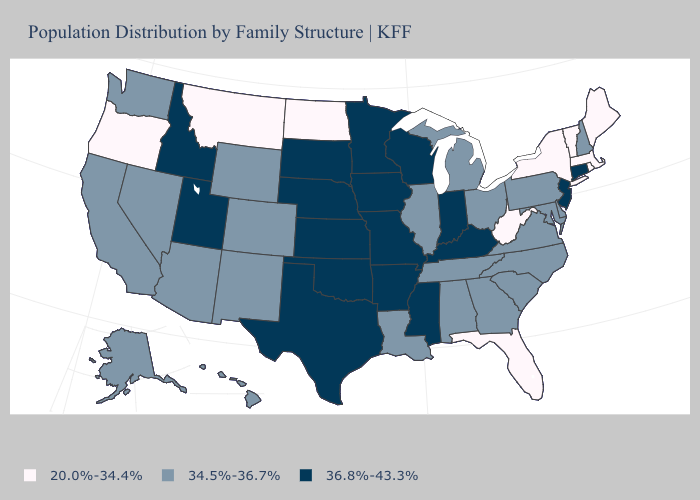Does Montana have a higher value than Georgia?
Keep it brief. No. Name the states that have a value in the range 36.8%-43.3%?
Give a very brief answer. Arkansas, Connecticut, Idaho, Indiana, Iowa, Kansas, Kentucky, Minnesota, Mississippi, Missouri, Nebraska, New Jersey, Oklahoma, South Dakota, Texas, Utah, Wisconsin. Which states have the lowest value in the South?
Keep it brief. Florida, West Virginia. What is the highest value in the USA?
Short answer required. 36.8%-43.3%. How many symbols are there in the legend?
Answer briefly. 3. What is the value of Iowa?
Write a very short answer. 36.8%-43.3%. Among the states that border Tennessee , which have the highest value?
Quick response, please. Arkansas, Kentucky, Mississippi, Missouri. What is the lowest value in the West?
Short answer required. 20.0%-34.4%. Name the states that have a value in the range 20.0%-34.4%?
Give a very brief answer. Florida, Maine, Massachusetts, Montana, New York, North Dakota, Oregon, Rhode Island, Vermont, West Virginia. Name the states that have a value in the range 34.5%-36.7%?
Give a very brief answer. Alabama, Alaska, Arizona, California, Colorado, Delaware, Georgia, Hawaii, Illinois, Louisiana, Maryland, Michigan, Nevada, New Hampshire, New Mexico, North Carolina, Ohio, Pennsylvania, South Carolina, Tennessee, Virginia, Washington, Wyoming. Among the states that border Alabama , does Mississippi have the highest value?
Quick response, please. Yes. How many symbols are there in the legend?
Be succinct. 3. Name the states that have a value in the range 36.8%-43.3%?
Write a very short answer. Arkansas, Connecticut, Idaho, Indiana, Iowa, Kansas, Kentucky, Minnesota, Mississippi, Missouri, Nebraska, New Jersey, Oklahoma, South Dakota, Texas, Utah, Wisconsin. Among the states that border Oregon , does Idaho have the highest value?
Write a very short answer. Yes. Does Tennessee have the highest value in the USA?
Be succinct. No. 